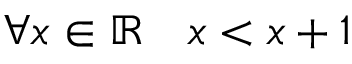Convert formula to latex. <formula><loc_0><loc_0><loc_500><loc_500>\forall x \in \mathbb { R } \quad x < x + 1</formula> 